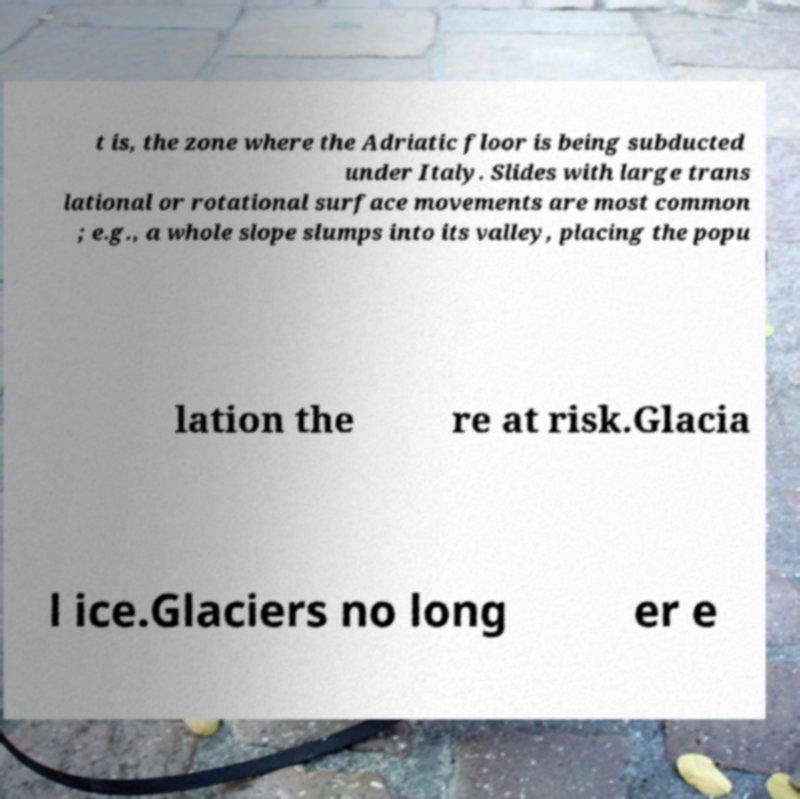Please identify and transcribe the text found in this image. t is, the zone where the Adriatic floor is being subducted under Italy. Slides with large trans lational or rotational surface movements are most common ; e.g., a whole slope slumps into its valley, placing the popu lation the re at risk.Glacia l ice.Glaciers no long er e 